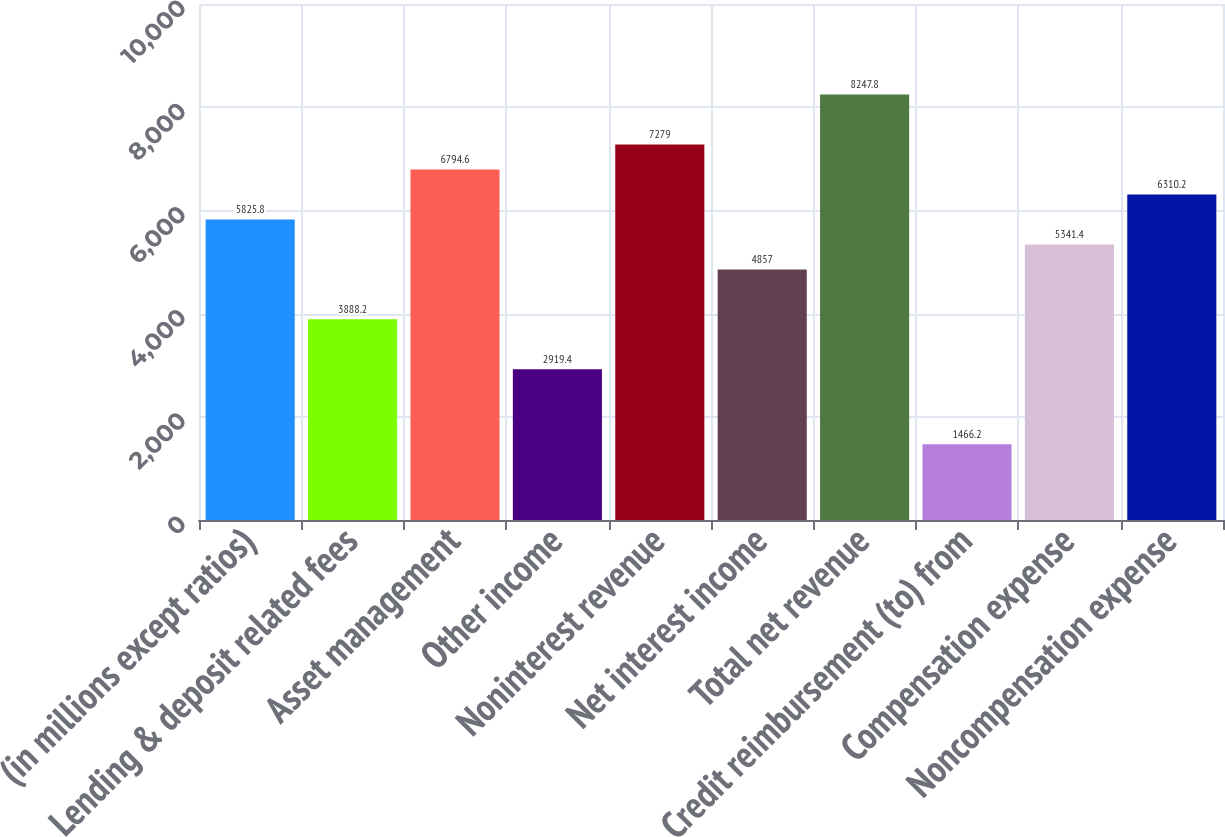<chart> <loc_0><loc_0><loc_500><loc_500><bar_chart><fcel>(in millions except ratios)<fcel>Lending & deposit related fees<fcel>Asset management<fcel>Other income<fcel>Noninterest revenue<fcel>Net interest income<fcel>Total net revenue<fcel>Credit reimbursement (to) from<fcel>Compensation expense<fcel>Noncompensation expense<nl><fcel>5825.8<fcel>3888.2<fcel>6794.6<fcel>2919.4<fcel>7279<fcel>4857<fcel>8247.8<fcel>1466.2<fcel>5341.4<fcel>6310.2<nl></chart> 